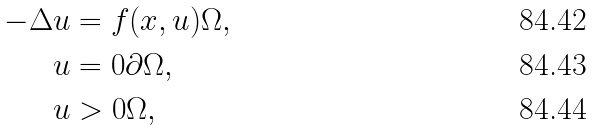<formula> <loc_0><loc_0><loc_500><loc_500>- \Delta u & = f ( x , u ) \Omega , \\ u & = 0 \partial \Omega , \\ u & > 0 \Omega ,</formula> 